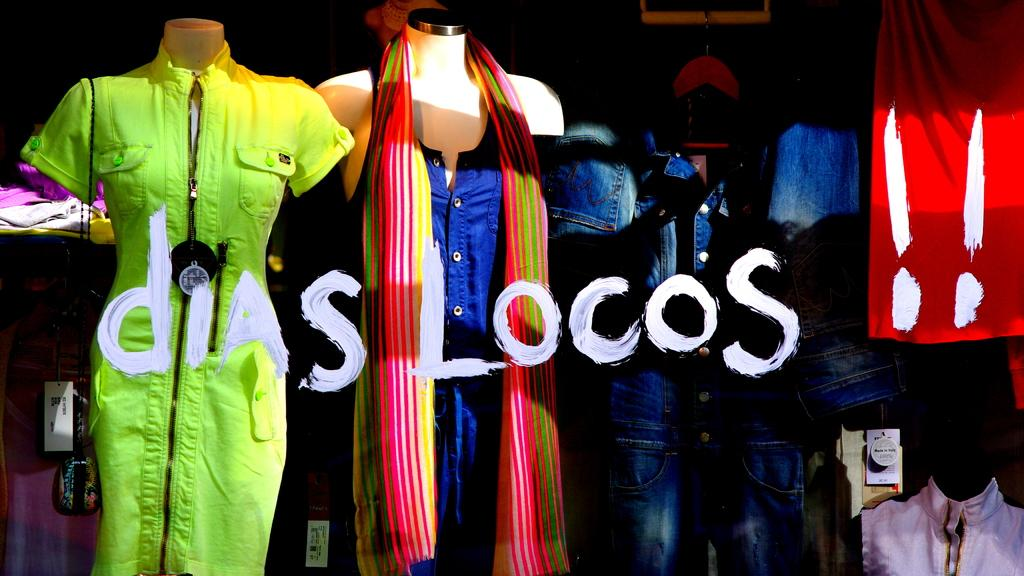What type of figures are in the image? There are mannequins in the image. What are the mannequins wearing? The mannequins are wearing dresses. Is there any text present in the image? Yes, there is text present in the image. What type of winter activity is the mannequin participating in the image? There is no winter activity or indication of winter in the image; it features mannequins wearing dresses and text. What month is depicted on the calendar in the image? There is no calendar present in the image. 